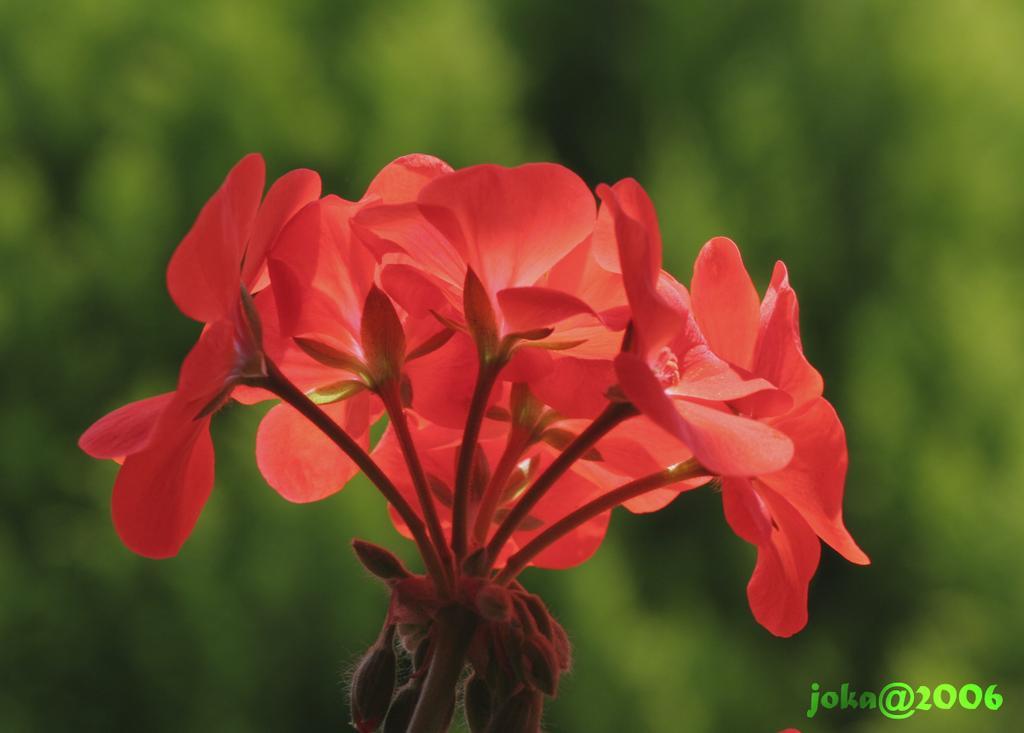Describe this image in one or two sentences. In the middle of the image, there is a plant having orange color flowers. In the bottom right, there is a watermark. And the background is blurred. 